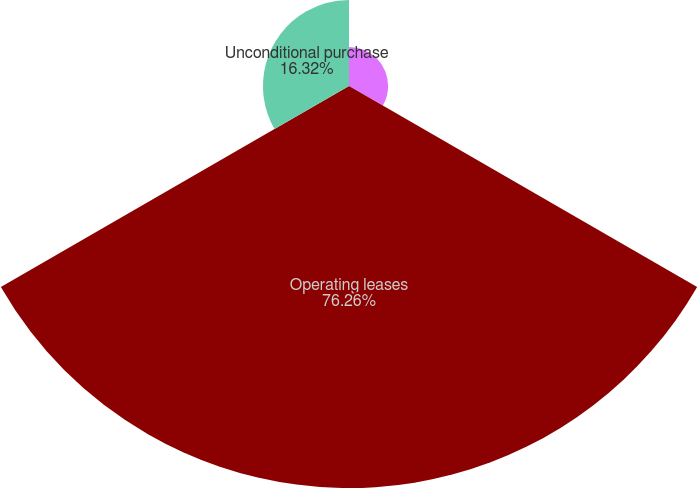Convert chart to OTSL. <chart><loc_0><loc_0><loc_500><loc_500><pie_chart><fcel>Capital lease obligations (2)<fcel>Operating leases<fcel>Unconditional purchase<nl><fcel>7.42%<fcel>76.26%<fcel>16.32%<nl></chart> 